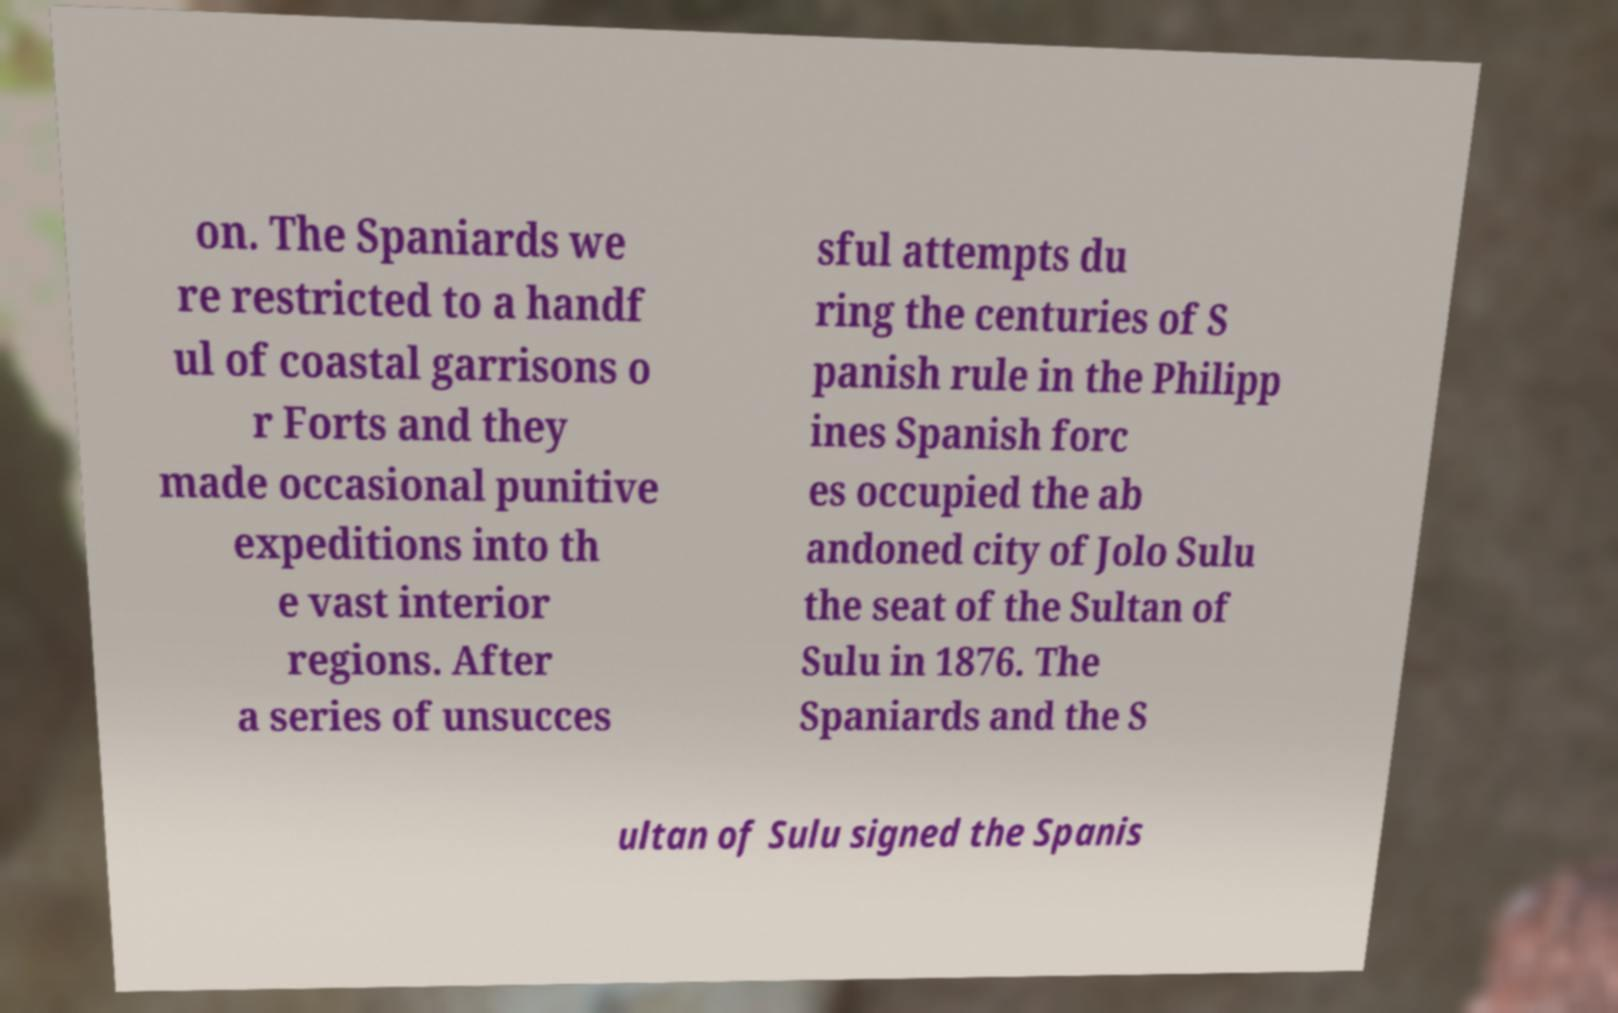Can you read and provide the text displayed in the image?This photo seems to have some interesting text. Can you extract and type it out for me? on. The Spaniards we re restricted to a handf ul of coastal garrisons o r Forts and they made occasional punitive expeditions into th e vast interior regions. After a series of unsucces sful attempts du ring the centuries of S panish rule in the Philipp ines Spanish forc es occupied the ab andoned city of Jolo Sulu the seat of the Sultan of Sulu in 1876. The Spaniards and the S ultan of Sulu signed the Spanis 